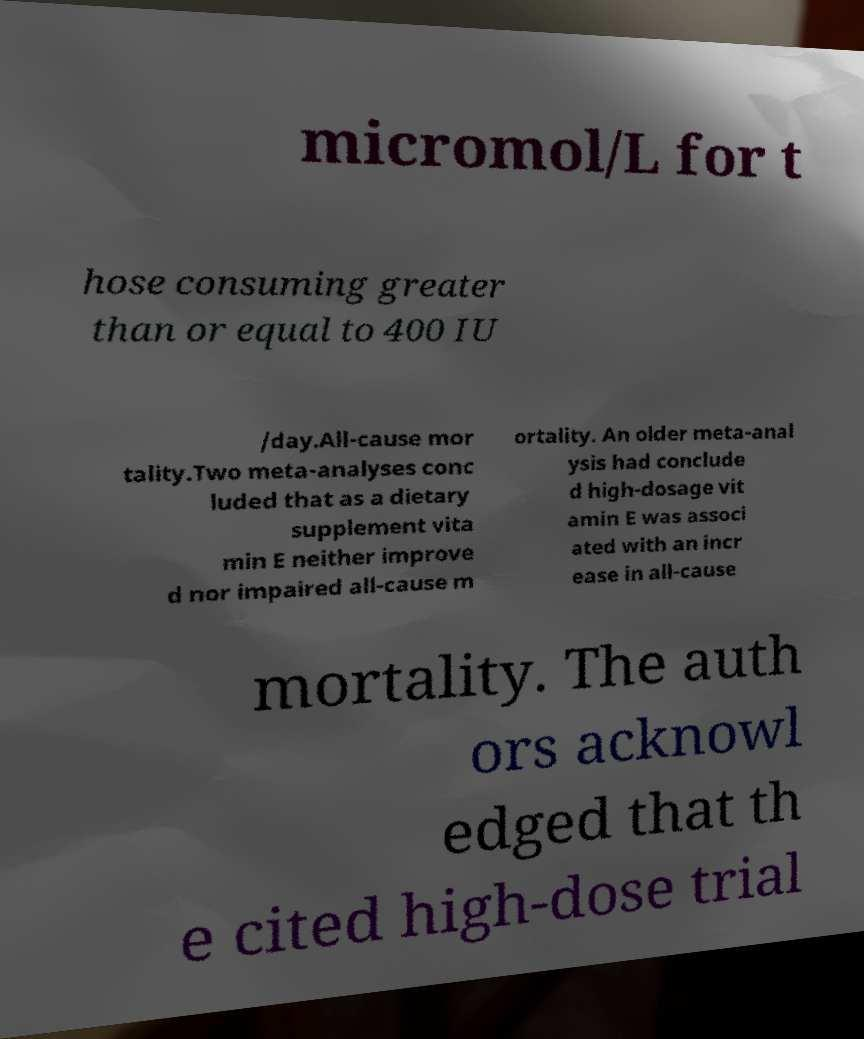Can you accurately transcribe the text from the provided image for me? micromol/L for t hose consuming greater than or equal to 400 IU /day.All-cause mor tality.Two meta-analyses conc luded that as a dietary supplement vita min E neither improve d nor impaired all-cause m ortality. An older meta-anal ysis had conclude d high-dosage vit amin E was associ ated with an incr ease in all-cause mortality. The auth ors acknowl edged that th e cited high-dose trial 